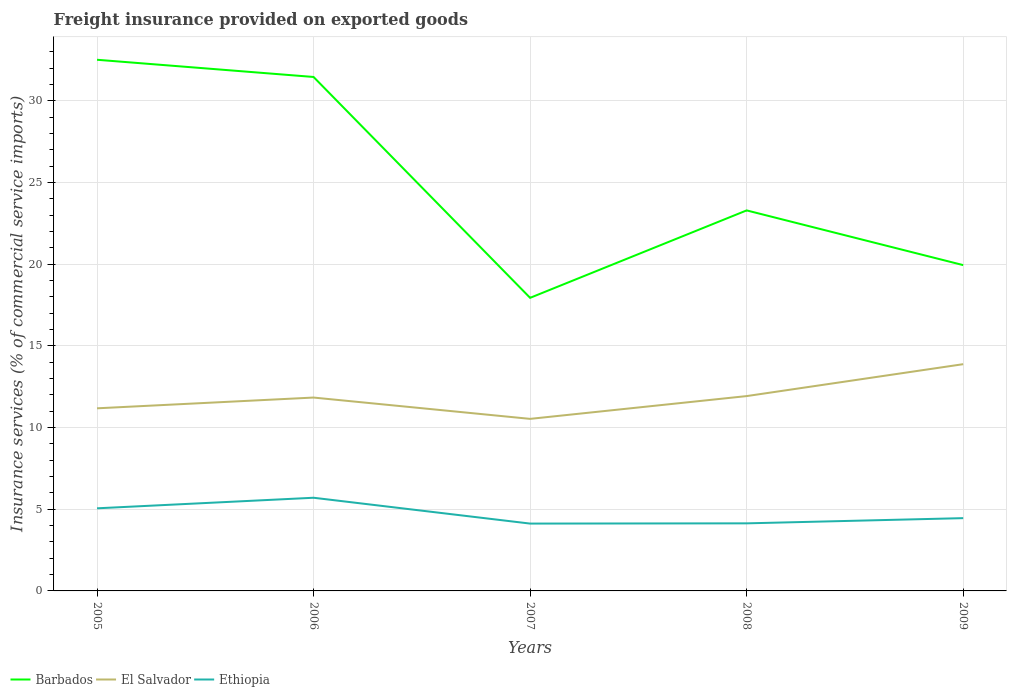How many different coloured lines are there?
Provide a succinct answer. 3. Is the number of lines equal to the number of legend labels?
Offer a terse response. Yes. Across all years, what is the maximum freight insurance provided on exported goods in Barbados?
Provide a short and direct response. 17.95. In which year was the freight insurance provided on exported goods in Ethiopia maximum?
Your answer should be very brief. 2007. What is the total freight insurance provided on exported goods in Barbados in the graph?
Provide a succinct answer. 8.17. What is the difference between the highest and the second highest freight insurance provided on exported goods in Barbados?
Your answer should be very brief. 14.58. Is the freight insurance provided on exported goods in Barbados strictly greater than the freight insurance provided on exported goods in Ethiopia over the years?
Keep it short and to the point. No. Are the values on the major ticks of Y-axis written in scientific E-notation?
Offer a terse response. No. Where does the legend appear in the graph?
Provide a short and direct response. Bottom left. How are the legend labels stacked?
Provide a short and direct response. Horizontal. What is the title of the graph?
Provide a succinct answer. Freight insurance provided on exported goods. What is the label or title of the Y-axis?
Give a very brief answer. Insurance services (% of commercial service imports). What is the Insurance services (% of commercial service imports) in Barbados in 2005?
Your response must be concise. 32.52. What is the Insurance services (% of commercial service imports) of El Salvador in 2005?
Provide a short and direct response. 11.18. What is the Insurance services (% of commercial service imports) of Ethiopia in 2005?
Your response must be concise. 5.06. What is the Insurance services (% of commercial service imports) in Barbados in 2006?
Your answer should be very brief. 31.47. What is the Insurance services (% of commercial service imports) in El Salvador in 2006?
Provide a succinct answer. 11.84. What is the Insurance services (% of commercial service imports) in Ethiopia in 2006?
Provide a succinct answer. 5.7. What is the Insurance services (% of commercial service imports) in Barbados in 2007?
Your answer should be very brief. 17.95. What is the Insurance services (% of commercial service imports) of El Salvador in 2007?
Provide a short and direct response. 10.53. What is the Insurance services (% of commercial service imports) in Ethiopia in 2007?
Ensure brevity in your answer.  4.12. What is the Insurance services (% of commercial service imports) of Barbados in 2008?
Provide a short and direct response. 23.3. What is the Insurance services (% of commercial service imports) of El Salvador in 2008?
Provide a succinct answer. 11.93. What is the Insurance services (% of commercial service imports) in Ethiopia in 2008?
Make the answer very short. 4.14. What is the Insurance services (% of commercial service imports) of Barbados in 2009?
Your answer should be compact. 19.95. What is the Insurance services (% of commercial service imports) of El Salvador in 2009?
Ensure brevity in your answer.  13.88. What is the Insurance services (% of commercial service imports) in Ethiopia in 2009?
Offer a terse response. 4.46. Across all years, what is the maximum Insurance services (% of commercial service imports) in Barbados?
Your answer should be compact. 32.52. Across all years, what is the maximum Insurance services (% of commercial service imports) of El Salvador?
Provide a succinct answer. 13.88. Across all years, what is the maximum Insurance services (% of commercial service imports) in Ethiopia?
Your response must be concise. 5.7. Across all years, what is the minimum Insurance services (% of commercial service imports) of Barbados?
Your answer should be compact. 17.95. Across all years, what is the minimum Insurance services (% of commercial service imports) in El Salvador?
Provide a succinct answer. 10.53. Across all years, what is the minimum Insurance services (% of commercial service imports) of Ethiopia?
Your response must be concise. 4.12. What is the total Insurance services (% of commercial service imports) of Barbados in the graph?
Offer a terse response. 125.18. What is the total Insurance services (% of commercial service imports) in El Salvador in the graph?
Provide a short and direct response. 59.37. What is the total Insurance services (% of commercial service imports) in Ethiopia in the graph?
Offer a terse response. 23.48. What is the difference between the Insurance services (% of commercial service imports) in Barbados in 2005 and that in 2006?
Your response must be concise. 1.05. What is the difference between the Insurance services (% of commercial service imports) in El Salvador in 2005 and that in 2006?
Your answer should be compact. -0.66. What is the difference between the Insurance services (% of commercial service imports) of Ethiopia in 2005 and that in 2006?
Make the answer very short. -0.65. What is the difference between the Insurance services (% of commercial service imports) in Barbados in 2005 and that in 2007?
Provide a succinct answer. 14.58. What is the difference between the Insurance services (% of commercial service imports) in El Salvador in 2005 and that in 2007?
Offer a very short reply. 0.65. What is the difference between the Insurance services (% of commercial service imports) of Ethiopia in 2005 and that in 2007?
Keep it short and to the point. 0.94. What is the difference between the Insurance services (% of commercial service imports) in Barbados in 2005 and that in 2008?
Offer a terse response. 9.22. What is the difference between the Insurance services (% of commercial service imports) in El Salvador in 2005 and that in 2008?
Your answer should be very brief. -0.75. What is the difference between the Insurance services (% of commercial service imports) of Ethiopia in 2005 and that in 2008?
Provide a succinct answer. 0.92. What is the difference between the Insurance services (% of commercial service imports) in Barbados in 2005 and that in 2009?
Ensure brevity in your answer.  12.57. What is the difference between the Insurance services (% of commercial service imports) of El Salvador in 2005 and that in 2009?
Offer a very short reply. -2.7. What is the difference between the Insurance services (% of commercial service imports) of Ethiopia in 2005 and that in 2009?
Provide a short and direct response. 0.6. What is the difference between the Insurance services (% of commercial service imports) of Barbados in 2006 and that in 2007?
Your response must be concise. 13.52. What is the difference between the Insurance services (% of commercial service imports) in El Salvador in 2006 and that in 2007?
Make the answer very short. 1.3. What is the difference between the Insurance services (% of commercial service imports) of Ethiopia in 2006 and that in 2007?
Provide a short and direct response. 1.58. What is the difference between the Insurance services (% of commercial service imports) of Barbados in 2006 and that in 2008?
Keep it short and to the point. 8.17. What is the difference between the Insurance services (% of commercial service imports) of El Salvador in 2006 and that in 2008?
Offer a terse response. -0.09. What is the difference between the Insurance services (% of commercial service imports) of Ethiopia in 2006 and that in 2008?
Keep it short and to the point. 1.57. What is the difference between the Insurance services (% of commercial service imports) in Barbados in 2006 and that in 2009?
Provide a succinct answer. 11.52. What is the difference between the Insurance services (% of commercial service imports) in El Salvador in 2006 and that in 2009?
Offer a very short reply. -2.04. What is the difference between the Insurance services (% of commercial service imports) of Ethiopia in 2006 and that in 2009?
Give a very brief answer. 1.25. What is the difference between the Insurance services (% of commercial service imports) in Barbados in 2007 and that in 2008?
Your answer should be very brief. -5.35. What is the difference between the Insurance services (% of commercial service imports) of El Salvador in 2007 and that in 2008?
Provide a succinct answer. -1.39. What is the difference between the Insurance services (% of commercial service imports) of Ethiopia in 2007 and that in 2008?
Ensure brevity in your answer.  -0.01. What is the difference between the Insurance services (% of commercial service imports) in Barbados in 2007 and that in 2009?
Your answer should be compact. -2. What is the difference between the Insurance services (% of commercial service imports) of El Salvador in 2007 and that in 2009?
Ensure brevity in your answer.  -3.35. What is the difference between the Insurance services (% of commercial service imports) in Ethiopia in 2007 and that in 2009?
Keep it short and to the point. -0.33. What is the difference between the Insurance services (% of commercial service imports) in Barbados in 2008 and that in 2009?
Your answer should be very brief. 3.35. What is the difference between the Insurance services (% of commercial service imports) of El Salvador in 2008 and that in 2009?
Your answer should be very brief. -1.95. What is the difference between the Insurance services (% of commercial service imports) of Ethiopia in 2008 and that in 2009?
Give a very brief answer. -0.32. What is the difference between the Insurance services (% of commercial service imports) of Barbados in 2005 and the Insurance services (% of commercial service imports) of El Salvador in 2006?
Your answer should be very brief. 20.68. What is the difference between the Insurance services (% of commercial service imports) in Barbados in 2005 and the Insurance services (% of commercial service imports) in Ethiopia in 2006?
Your response must be concise. 26.82. What is the difference between the Insurance services (% of commercial service imports) in El Salvador in 2005 and the Insurance services (% of commercial service imports) in Ethiopia in 2006?
Provide a succinct answer. 5.48. What is the difference between the Insurance services (% of commercial service imports) of Barbados in 2005 and the Insurance services (% of commercial service imports) of El Salvador in 2007?
Ensure brevity in your answer.  21.99. What is the difference between the Insurance services (% of commercial service imports) of Barbados in 2005 and the Insurance services (% of commercial service imports) of Ethiopia in 2007?
Make the answer very short. 28.4. What is the difference between the Insurance services (% of commercial service imports) in El Salvador in 2005 and the Insurance services (% of commercial service imports) in Ethiopia in 2007?
Your response must be concise. 7.06. What is the difference between the Insurance services (% of commercial service imports) of Barbados in 2005 and the Insurance services (% of commercial service imports) of El Salvador in 2008?
Your answer should be compact. 20.59. What is the difference between the Insurance services (% of commercial service imports) of Barbados in 2005 and the Insurance services (% of commercial service imports) of Ethiopia in 2008?
Your response must be concise. 28.38. What is the difference between the Insurance services (% of commercial service imports) in El Salvador in 2005 and the Insurance services (% of commercial service imports) in Ethiopia in 2008?
Give a very brief answer. 7.04. What is the difference between the Insurance services (% of commercial service imports) in Barbados in 2005 and the Insurance services (% of commercial service imports) in El Salvador in 2009?
Provide a short and direct response. 18.64. What is the difference between the Insurance services (% of commercial service imports) of Barbados in 2005 and the Insurance services (% of commercial service imports) of Ethiopia in 2009?
Give a very brief answer. 28.06. What is the difference between the Insurance services (% of commercial service imports) of El Salvador in 2005 and the Insurance services (% of commercial service imports) of Ethiopia in 2009?
Your answer should be very brief. 6.72. What is the difference between the Insurance services (% of commercial service imports) of Barbados in 2006 and the Insurance services (% of commercial service imports) of El Salvador in 2007?
Your response must be concise. 20.93. What is the difference between the Insurance services (% of commercial service imports) of Barbados in 2006 and the Insurance services (% of commercial service imports) of Ethiopia in 2007?
Ensure brevity in your answer.  27.35. What is the difference between the Insurance services (% of commercial service imports) of El Salvador in 2006 and the Insurance services (% of commercial service imports) of Ethiopia in 2007?
Your answer should be very brief. 7.72. What is the difference between the Insurance services (% of commercial service imports) in Barbados in 2006 and the Insurance services (% of commercial service imports) in El Salvador in 2008?
Provide a succinct answer. 19.54. What is the difference between the Insurance services (% of commercial service imports) in Barbados in 2006 and the Insurance services (% of commercial service imports) in Ethiopia in 2008?
Provide a short and direct response. 27.33. What is the difference between the Insurance services (% of commercial service imports) in El Salvador in 2006 and the Insurance services (% of commercial service imports) in Ethiopia in 2008?
Give a very brief answer. 7.7. What is the difference between the Insurance services (% of commercial service imports) of Barbados in 2006 and the Insurance services (% of commercial service imports) of El Salvador in 2009?
Offer a very short reply. 17.59. What is the difference between the Insurance services (% of commercial service imports) in Barbados in 2006 and the Insurance services (% of commercial service imports) in Ethiopia in 2009?
Your answer should be compact. 27.01. What is the difference between the Insurance services (% of commercial service imports) in El Salvador in 2006 and the Insurance services (% of commercial service imports) in Ethiopia in 2009?
Your response must be concise. 7.38. What is the difference between the Insurance services (% of commercial service imports) in Barbados in 2007 and the Insurance services (% of commercial service imports) in El Salvador in 2008?
Ensure brevity in your answer.  6.02. What is the difference between the Insurance services (% of commercial service imports) of Barbados in 2007 and the Insurance services (% of commercial service imports) of Ethiopia in 2008?
Offer a terse response. 13.81. What is the difference between the Insurance services (% of commercial service imports) of El Salvador in 2007 and the Insurance services (% of commercial service imports) of Ethiopia in 2008?
Provide a short and direct response. 6.4. What is the difference between the Insurance services (% of commercial service imports) in Barbados in 2007 and the Insurance services (% of commercial service imports) in El Salvador in 2009?
Offer a terse response. 4.06. What is the difference between the Insurance services (% of commercial service imports) of Barbados in 2007 and the Insurance services (% of commercial service imports) of Ethiopia in 2009?
Keep it short and to the point. 13.49. What is the difference between the Insurance services (% of commercial service imports) in El Salvador in 2007 and the Insurance services (% of commercial service imports) in Ethiopia in 2009?
Keep it short and to the point. 6.08. What is the difference between the Insurance services (% of commercial service imports) of Barbados in 2008 and the Insurance services (% of commercial service imports) of El Salvador in 2009?
Your response must be concise. 9.41. What is the difference between the Insurance services (% of commercial service imports) in Barbados in 2008 and the Insurance services (% of commercial service imports) in Ethiopia in 2009?
Provide a short and direct response. 18.84. What is the difference between the Insurance services (% of commercial service imports) of El Salvador in 2008 and the Insurance services (% of commercial service imports) of Ethiopia in 2009?
Keep it short and to the point. 7.47. What is the average Insurance services (% of commercial service imports) in Barbados per year?
Provide a succinct answer. 25.04. What is the average Insurance services (% of commercial service imports) in El Salvador per year?
Your response must be concise. 11.87. What is the average Insurance services (% of commercial service imports) of Ethiopia per year?
Provide a succinct answer. 4.7. In the year 2005, what is the difference between the Insurance services (% of commercial service imports) of Barbados and Insurance services (% of commercial service imports) of El Salvador?
Give a very brief answer. 21.34. In the year 2005, what is the difference between the Insurance services (% of commercial service imports) of Barbados and Insurance services (% of commercial service imports) of Ethiopia?
Provide a succinct answer. 27.46. In the year 2005, what is the difference between the Insurance services (% of commercial service imports) in El Salvador and Insurance services (% of commercial service imports) in Ethiopia?
Provide a short and direct response. 6.12. In the year 2006, what is the difference between the Insurance services (% of commercial service imports) of Barbados and Insurance services (% of commercial service imports) of El Salvador?
Your response must be concise. 19.63. In the year 2006, what is the difference between the Insurance services (% of commercial service imports) in Barbados and Insurance services (% of commercial service imports) in Ethiopia?
Your response must be concise. 25.76. In the year 2006, what is the difference between the Insurance services (% of commercial service imports) in El Salvador and Insurance services (% of commercial service imports) in Ethiopia?
Your answer should be compact. 6.13. In the year 2007, what is the difference between the Insurance services (% of commercial service imports) of Barbados and Insurance services (% of commercial service imports) of El Salvador?
Ensure brevity in your answer.  7.41. In the year 2007, what is the difference between the Insurance services (% of commercial service imports) of Barbados and Insurance services (% of commercial service imports) of Ethiopia?
Give a very brief answer. 13.82. In the year 2007, what is the difference between the Insurance services (% of commercial service imports) of El Salvador and Insurance services (% of commercial service imports) of Ethiopia?
Provide a succinct answer. 6.41. In the year 2008, what is the difference between the Insurance services (% of commercial service imports) in Barbados and Insurance services (% of commercial service imports) in El Salvador?
Provide a succinct answer. 11.37. In the year 2008, what is the difference between the Insurance services (% of commercial service imports) of Barbados and Insurance services (% of commercial service imports) of Ethiopia?
Give a very brief answer. 19.16. In the year 2008, what is the difference between the Insurance services (% of commercial service imports) of El Salvador and Insurance services (% of commercial service imports) of Ethiopia?
Provide a succinct answer. 7.79. In the year 2009, what is the difference between the Insurance services (% of commercial service imports) in Barbados and Insurance services (% of commercial service imports) in El Salvador?
Provide a short and direct response. 6.07. In the year 2009, what is the difference between the Insurance services (% of commercial service imports) of Barbados and Insurance services (% of commercial service imports) of Ethiopia?
Your answer should be very brief. 15.49. In the year 2009, what is the difference between the Insurance services (% of commercial service imports) in El Salvador and Insurance services (% of commercial service imports) in Ethiopia?
Give a very brief answer. 9.43. What is the ratio of the Insurance services (% of commercial service imports) in Barbados in 2005 to that in 2006?
Provide a succinct answer. 1.03. What is the ratio of the Insurance services (% of commercial service imports) in El Salvador in 2005 to that in 2006?
Your response must be concise. 0.94. What is the ratio of the Insurance services (% of commercial service imports) of Ethiopia in 2005 to that in 2006?
Give a very brief answer. 0.89. What is the ratio of the Insurance services (% of commercial service imports) of Barbados in 2005 to that in 2007?
Provide a short and direct response. 1.81. What is the ratio of the Insurance services (% of commercial service imports) of El Salvador in 2005 to that in 2007?
Offer a terse response. 1.06. What is the ratio of the Insurance services (% of commercial service imports) in Ethiopia in 2005 to that in 2007?
Give a very brief answer. 1.23. What is the ratio of the Insurance services (% of commercial service imports) in Barbados in 2005 to that in 2008?
Keep it short and to the point. 1.4. What is the ratio of the Insurance services (% of commercial service imports) of El Salvador in 2005 to that in 2008?
Keep it short and to the point. 0.94. What is the ratio of the Insurance services (% of commercial service imports) of Ethiopia in 2005 to that in 2008?
Provide a short and direct response. 1.22. What is the ratio of the Insurance services (% of commercial service imports) in Barbados in 2005 to that in 2009?
Provide a short and direct response. 1.63. What is the ratio of the Insurance services (% of commercial service imports) of El Salvador in 2005 to that in 2009?
Keep it short and to the point. 0.81. What is the ratio of the Insurance services (% of commercial service imports) in Ethiopia in 2005 to that in 2009?
Make the answer very short. 1.14. What is the ratio of the Insurance services (% of commercial service imports) in Barbados in 2006 to that in 2007?
Provide a succinct answer. 1.75. What is the ratio of the Insurance services (% of commercial service imports) in El Salvador in 2006 to that in 2007?
Offer a very short reply. 1.12. What is the ratio of the Insurance services (% of commercial service imports) in Ethiopia in 2006 to that in 2007?
Your response must be concise. 1.38. What is the ratio of the Insurance services (% of commercial service imports) in Barbados in 2006 to that in 2008?
Give a very brief answer. 1.35. What is the ratio of the Insurance services (% of commercial service imports) in El Salvador in 2006 to that in 2008?
Provide a succinct answer. 0.99. What is the ratio of the Insurance services (% of commercial service imports) in Ethiopia in 2006 to that in 2008?
Make the answer very short. 1.38. What is the ratio of the Insurance services (% of commercial service imports) of Barbados in 2006 to that in 2009?
Your answer should be compact. 1.58. What is the ratio of the Insurance services (% of commercial service imports) in El Salvador in 2006 to that in 2009?
Keep it short and to the point. 0.85. What is the ratio of the Insurance services (% of commercial service imports) in Ethiopia in 2006 to that in 2009?
Provide a short and direct response. 1.28. What is the ratio of the Insurance services (% of commercial service imports) in Barbados in 2007 to that in 2008?
Provide a short and direct response. 0.77. What is the ratio of the Insurance services (% of commercial service imports) in El Salvador in 2007 to that in 2008?
Keep it short and to the point. 0.88. What is the ratio of the Insurance services (% of commercial service imports) in Ethiopia in 2007 to that in 2008?
Your answer should be compact. 1. What is the ratio of the Insurance services (% of commercial service imports) in Barbados in 2007 to that in 2009?
Make the answer very short. 0.9. What is the ratio of the Insurance services (% of commercial service imports) in El Salvador in 2007 to that in 2009?
Provide a succinct answer. 0.76. What is the ratio of the Insurance services (% of commercial service imports) in Ethiopia in 2007 to that in 2009?
Your response must be concise. 0.93. What is the ratio of the Insurance services (% of commercial service imports) of Barbados in 2008 to that in 2009?
Your answer should be very brief. 1.17. What is the ratio of the Insurance services (% of commercial service imports) in El Salvador in 2008 to that in 2009?
Provide a short and direct response. 0.86. What is the ratio of the Insurance services (% of commercial service imports) in Ethiopia in 2008 to that in 2009?
Offer a terse response. 0.93. What is the difference between the highest and the second highest Insurance services (% of commercial service imports) in Barbados?
Your answer should be compact. 1.05. What is the difference between the highest and the second highest Insurance services (% of commercial service imports) of El Salvador?
Provide a succinct answer. 1.95. What is the difference between the highest and the second highest Insurance services (% of commercial service imports) in Ethiopia?
Give a very brief answer. 0.65. What is the difference between the highest and the lowest Insurance services (% of commercial service imports) of Barbados?
Offer a terse response. 14.58. What is the difference between the highest and the lowest Insurance services (% of commercial service imports) in El Salvador?
Your answer should be very brief. 3.35. What is the difference between the highest and the lowest Insurance services (% of commercial service imports) of Ethiopia?
Make the answer very short. 1.58. 